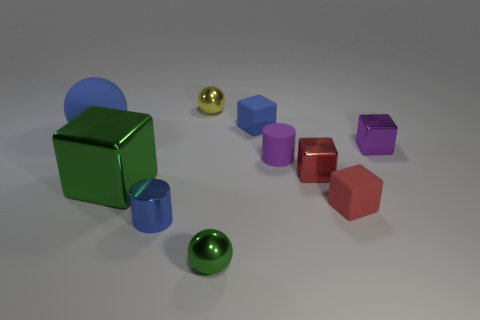What is the size of the rubber block that is in front of the tiny blue matte cube?
Keep it short and to the point. Small. There is a tiny shiny cylinder; does it have the same color as the matte thing that is on the left side of the blue shiny cylinder?
Make the answer very short. Yes. Are there any metal objects that have the same color as the rubber cylinder?
Provide a short and direct response. Yes. Does the tiny green ball have the same material as the cylinder behind the large shiny cube?
Ensure brevity in your answer.  No. How many large objects are purple cylinders or metallic blocks?
Provide a short and direct response. 1. What is the material of the large ball that is the same color as the tiny metal cylinder?
Provide a succinct answer. Rubber. Are there fewer shiny things than tiny purple matte blocks?
Offer a terse response. No. There is a cylinder in front of the green shiny cube; is its size the same as the metallic ball that is in front of the small blue metallic cylinder?
Your answer should be very brief. Yes. What number of brown objects are cylinders or metallic blocks?
Offer a terse response. 0. The ball that is the same color as the metal cylinder is what size?
Provide a short and direct response. Large. 